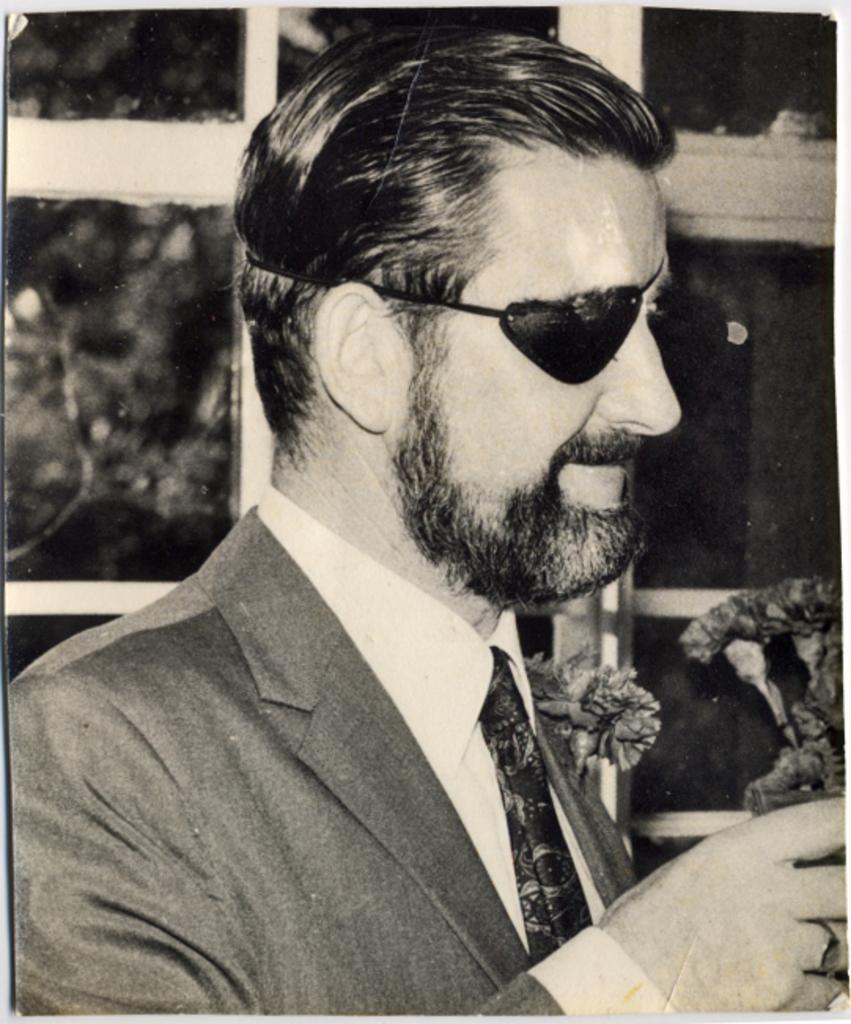How would you summarize this image in a sentence or two? In this image I can see a poster. A person is wearing suit and one eyed mask. There are plants and windows at the back. 